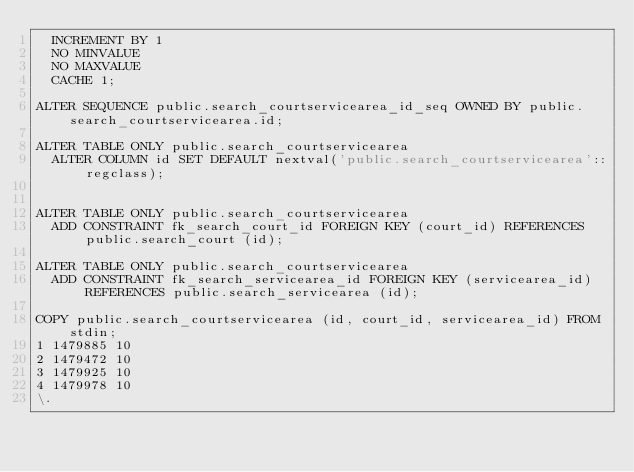<code> <loc_0><loc_0><loc_500><loc_500><_SQL_>	INCREMENT BY 1
	NO MINVALUE
	NO MAXVALUE
	CACHE 1;

ALTER SEQUENCE public.search_courtservicearea_id_seq OWNED BY public.search_courtservicearea.id;

ALTER TABLE ONLY public.search_courtservicearea
	ALTER COLUMN id SET DEFAULT nextval('public.search_courtservicearea'::regclass);


ALTER TABLE ONLY public.search_courtservicearea
	ADD CONSTRAINT fk_search_court_id FOREIGN KEY (court_id) REFERENCES public.search_court (id);

ALTER TABLE ONLY public.search_courtservicearea
	ADD CONSTRAINT fk_search_servicearea_id FOREIGN KEY (servicearea_id) REFERENCES public.search_servicearea (id);

COPY public.search_courtservicearea (id, court_id, servicearea_id) FROM stdin;
1	1479885	10
2	1479472	10
3	1479925	10
4	1479978	10
\.
</code> 